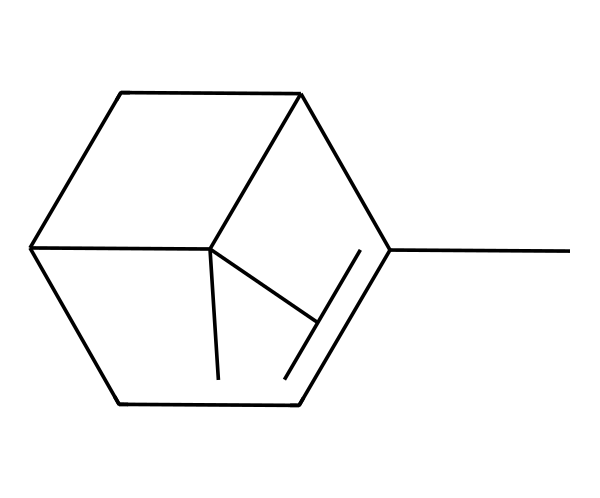What is the molecular formula of pinene? To determine the molecular formula from the SMILES representation, we count the carbon (C) and hydrogen (H) atoms. The SMILES shows 10 carbon atoms and 16 hydrogen atoms. Hence, the molecular formula is C10H16.
Answer: C10H16 How many rings are present in the structure of pinene? By analyzing the structure from the SMILES, we can identify the cyclic portions. Pinene has two rings in its structure.
Answer: 2 What feature in the structure suggests that pinene is a terpene? Terpenes are characterized by their isoprene units. The structure exhibits a carbon skeleton made from multiple isoprene units (5 carbon units), fitting the definition of terpenes.
Answer: isoprene units What is the significance of the double bonds in pinene? The presence of double bonds in the structure of pinene contributes to its reactivity and aroma, which is characteristic of many terpenes. In this structure, there are two double bonds, which enhance its properties.
Answer: reactivity Which part of the molecule is responsible for its pine-like scent? The specific arrangement of carbon and double bonds in the pinene structure leads to its characteristic aroma. The unique combination of these features creates the distinctive pine scent.
Answer: carbon and double bonds 